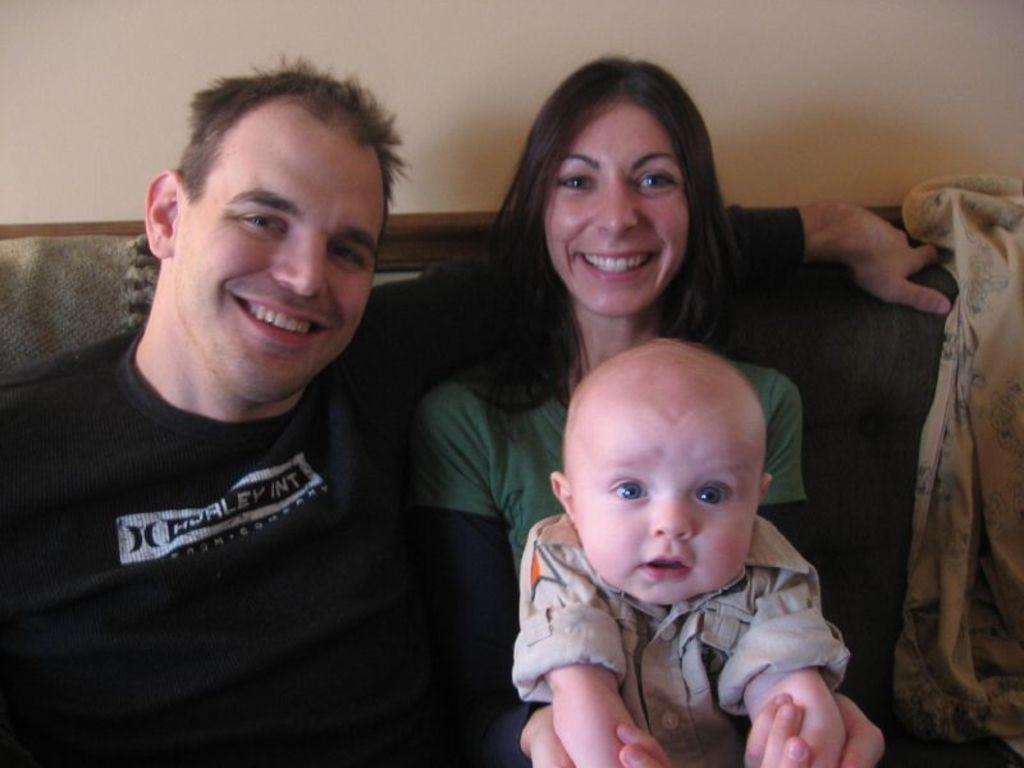How many people are in the image? There are two people in the image, a man and a woman. What is the woman doing in the image? The woman is sitting on a sofa. Is there anyone else on the sofa with the woman? Yes, there is a kid on the woman's lap. What can be seen on the sofa besides the people? There is an object on the sofa. What is visible behind the sofa? There is a wall behind the sofa. What type of yarn is the kid using to smash the question in the image? There is no yarn, smashing, or question present in the image. 